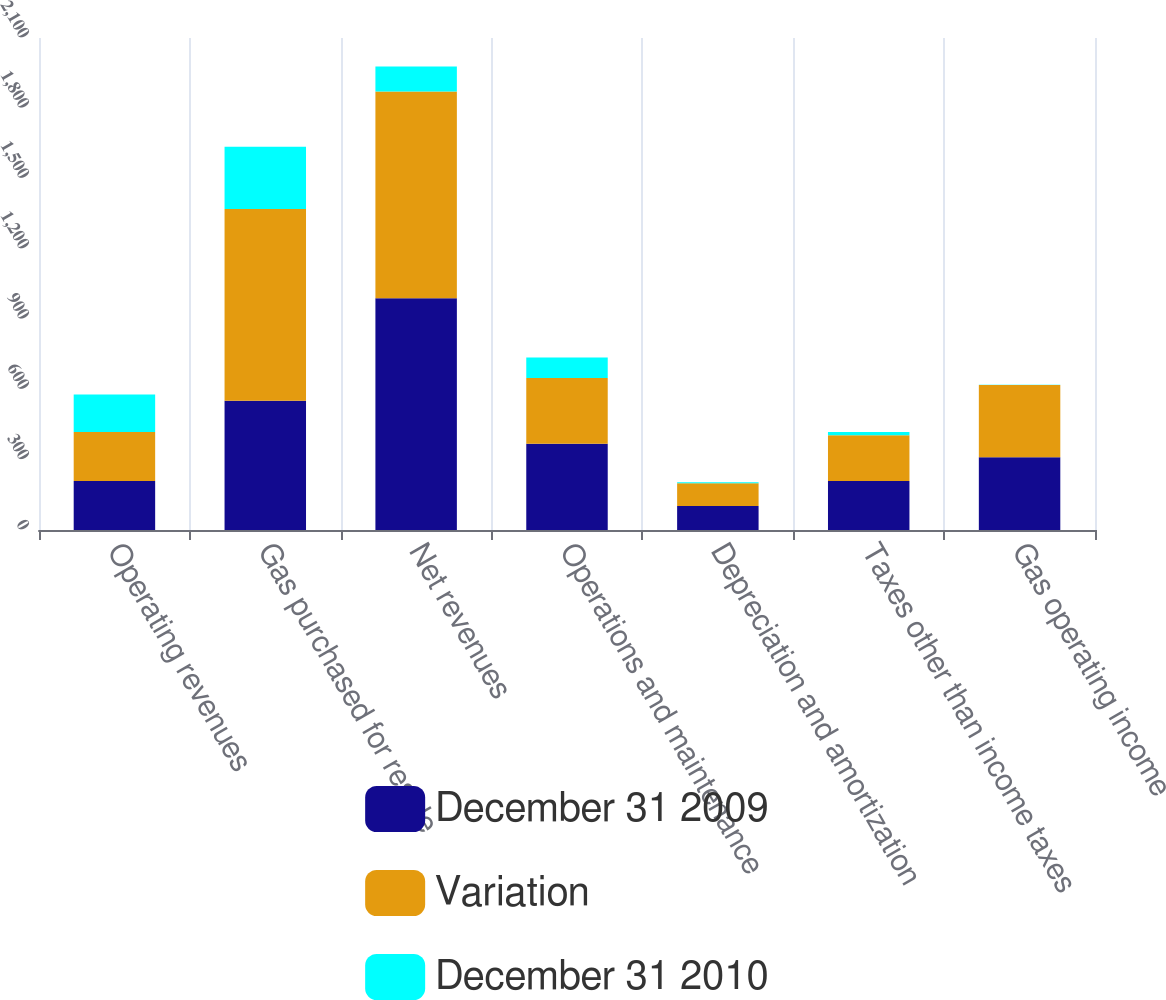Convert chart. <chart><loc_0><loc_0><loc_500><loc_500><stacked_bar_chart><ecel><fcel>Operating revenues<fcel>Gas purchased for resale<fcel>Net revenues<fcel>Operations and maintenance<fcel>Depreciation and amortization<fcel>Taxes other than income taxes<fcel>Gas operating income<nl><fcel>December 31 2009<fcel>209<fcel>552<fcel>989<fcel>368<fcel>102<fcel>209<fcel>310<nl><fcel>Variation<fcel>209<fcel>818<fcel>883<fcel>281<fcel>98<fcel>195<fcel>309<nl><fcel>December 31 2010<fcel>160<fcel>266<fcel>106<fcel>87<fcel>4<fcel>14<fcel>1<nl></chart> 